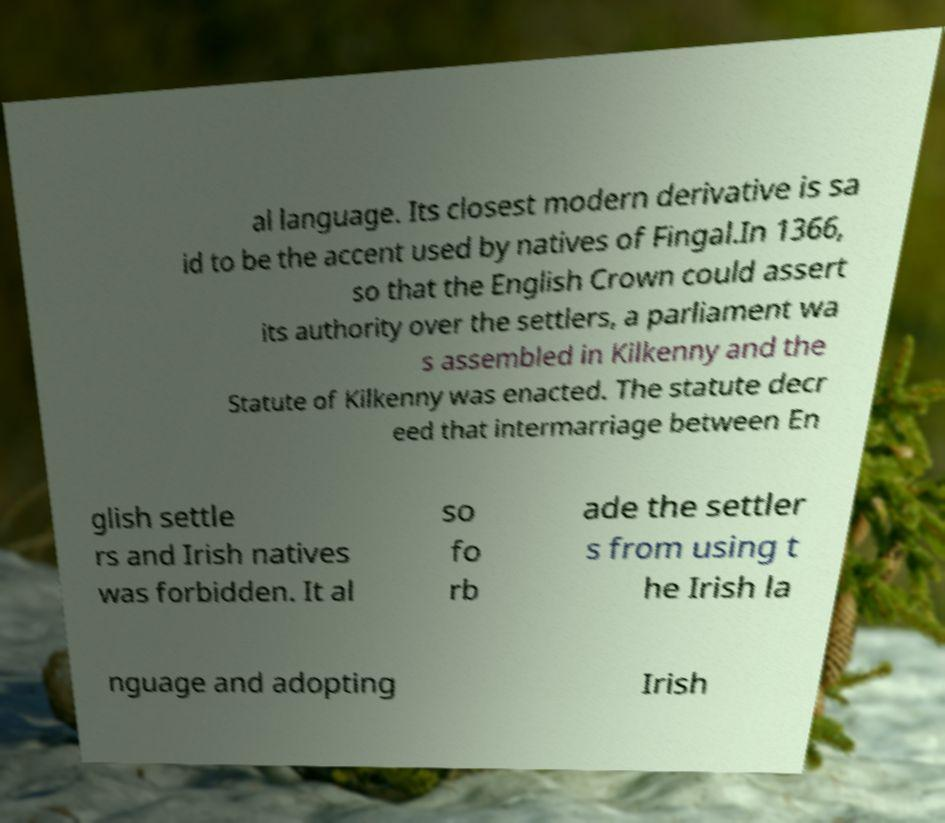There's text embedded in this image that I need extracted. Can you transcribe it verbatim? al language. Its closest modern derivative is sa id to be the accent used by natives of Fingal.In 1366, so that the English Crown could assert its authority over the settlers, a parliament wa s assembled in Kilkenny and the Statute of Kilkenny was enacted. The statute decr eed that intermarriage between En glish settle rs and Irish natives was forbidden. It al so fo rb ade the settler s from using t he Irish la nguage and adopting Irish 